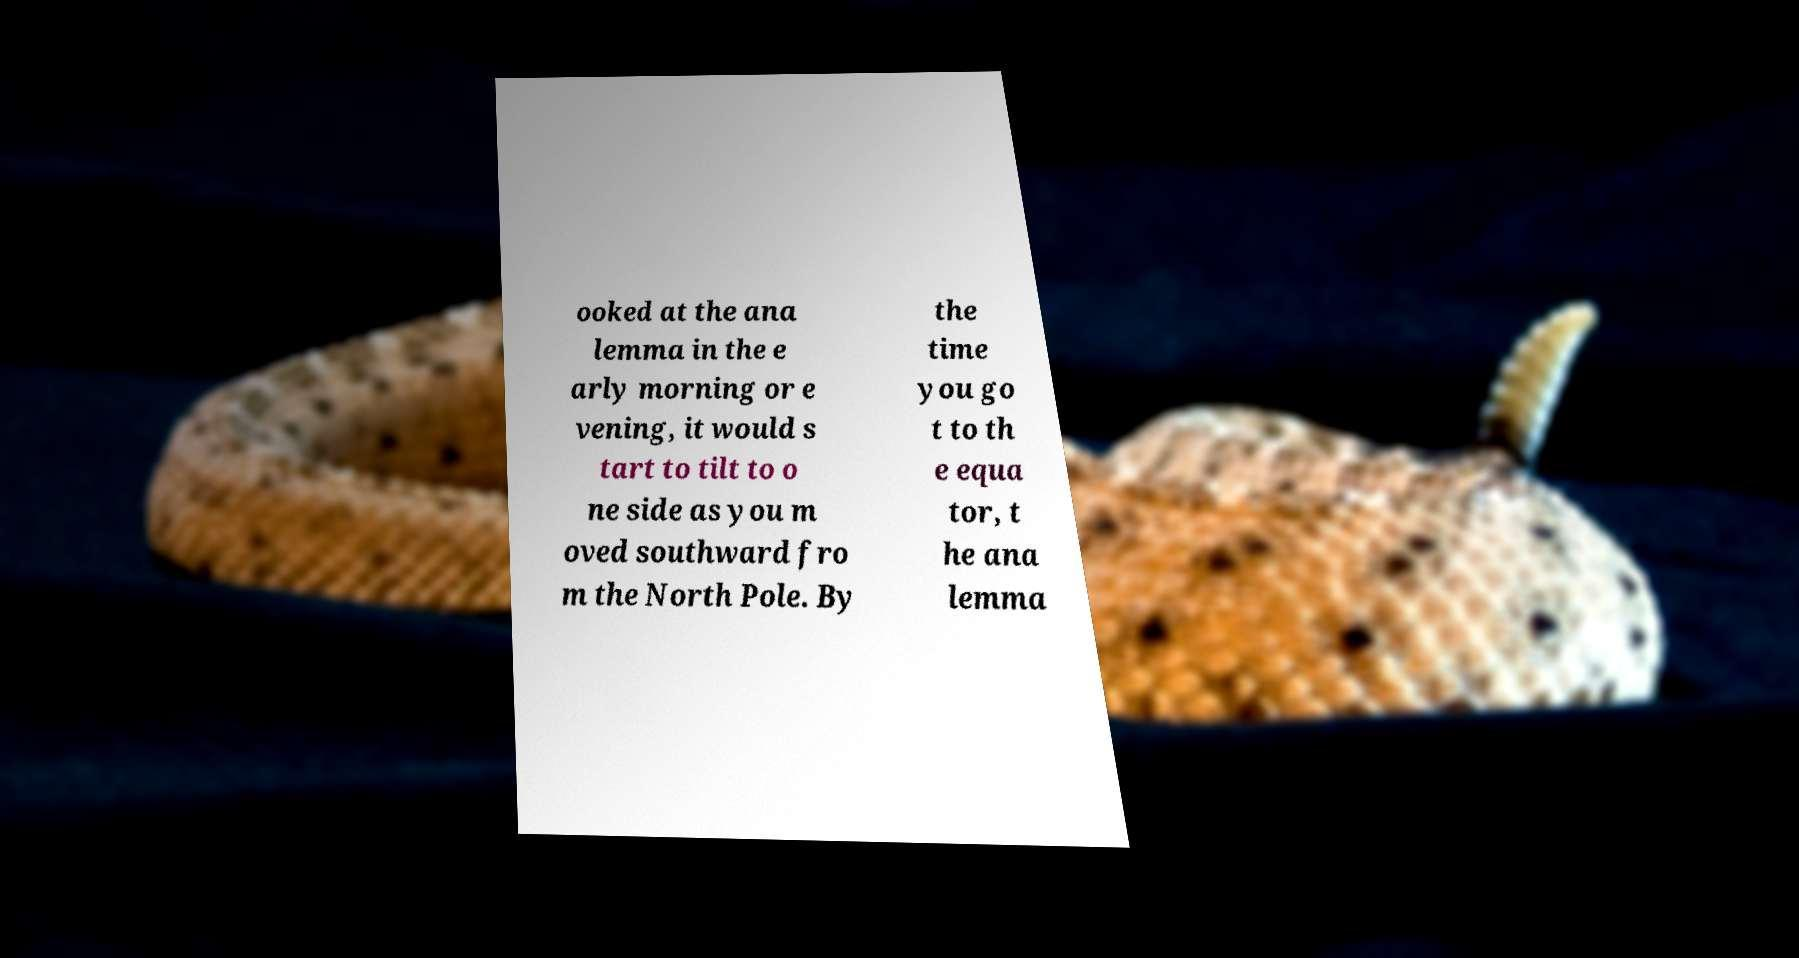Can you read and provide the text displayed in the image?This photo seems to have some interesting text. Can you extract and type it out for me? ooked at the ana lemma in the e arly morning or e vening, it would s tart to tilt to o ne side as you m oved southward fro m the North Pole. By the time you go t to th e equa tor, t he ana lemma 